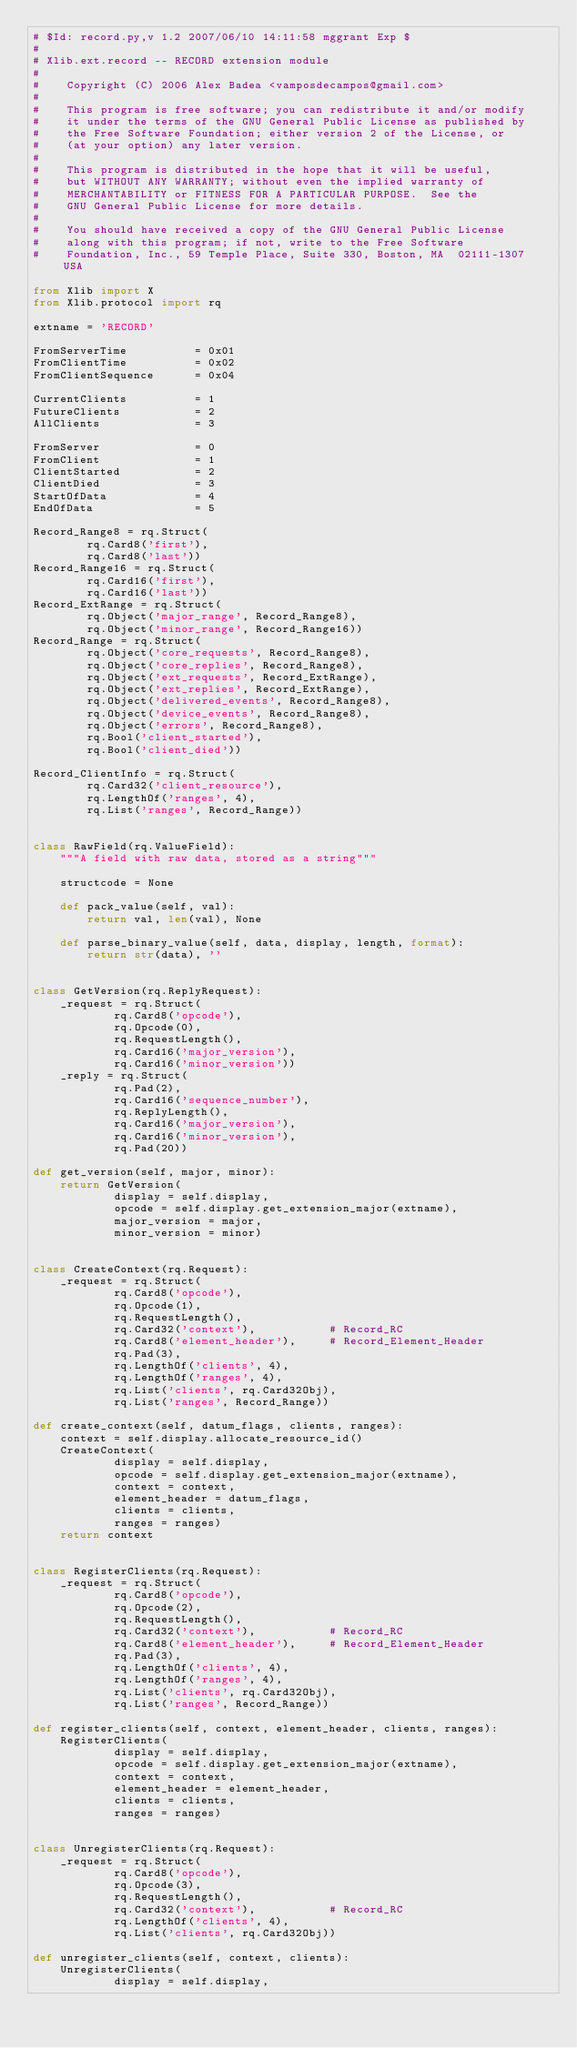Convert code to text. <code><loc_0><loc_0><loc_500><loc_500><_Python_># $Id: record.py,v 1.2 2007/06/10 14:11:58 mggrant Exp $
#
# Xlib.ext.record -- RECORD extension module
#
#    Copyright (C) 2006 Alex Badea <vamposdecampos@gmail.com>
#
#    This program is free software; you can redistribute it and/or modify
#    it under the terms of the GNU General Public License as published by
#    the Free Software Foundation; either version 2 of the License, or
#    (at your option) any later version.
#
#    This program is distributed in the hope that it will be useful,
#    but WITHOUT ANY WARRANTY; without even the implied warranty of
#    MERCHANTABILITY or FITNESS FOR A PARTICULAR PURPOSE.  See the
#    GNU General Public License for more details.
#
#    You should have received a copy of the GNU General Public License
#    along with this program; if not, write to the Free Software
#    Foundation, Inc., 59 Temple Place, Suite 330, Boston, MA  02111-1307  USA

from Xlib import X
from Xlib.protocol import rq

extname = 'RECORD'

FromServerTime          = 0x01
FromClientTime          = 0x02
FromClientSequence      = 0x04

CurrentClients          = 1
FutureClients           = 2
AllClients              = 3

FromServer              = 0
FromClient              = 1
ClientStarted           = 2
ClientDied              = 3
StartOfData             = 4
EndOfData               = 5

Record_Range8 = rq.Struct(
        rq.Card8('first'),
        rq.Card8('last'))
Record_Range16 = rq.Struct(
        rq.Card16('first'),
        rq.Card16('last'))
Record_ExtRange = rq.Struct(
        rq.Object('major_range', Record_Range8),
        rq.Object('minor_range', Record_Range16))
Record_Range = rq.Struct(
        rq.Object('core_requests', Record_Range8),
        rq.Object('core_replies', Record_Range8),
        rq.Object('ext_requests', Record_ExtRange),
        rq.Object('ext_replies', Record_ExtRange),
        rq.Object('delivered_events', Record_Range8),
        rq.Object('device_events', Record_Range8),
        rq.Object('errors', Record_Range8),
        rq.Bool('client_started'),
        rq.Bool('client_died'))

Record_ClientInfo = rq.Struct(
        rq.Card32('client_resource'),
        rq.LengthOf('ranges', 4),
        rq.List('ranges', Record_Range))


class RawField(rq.ValueField):
    """A field with raw data, stored as a string"""

    structcode = None

    def pack_value(self, val):
        return val, len(val), None

    def parse_binary_value(self, data, display, length, format):
        return str(data), ''


class GetVersion(rq.ReplyRequest):
    _request = rq.Struct(
            rq.Card8('opcode'),
            rq.Opcode(0),
            rq.RequestLength(),
            rq.Card16('major_version'),
            rq.Card16('minor_version'))
    _reply = rq.Struct(
            rq.Pad(2),
            rq.Card16('sequence_number'),
            rq.ReplyLength(),
            rq.Card16('major_version'),
            rq.Card16('minor_version'),
            rq.Pad(20))

def get_version(self, major, minor):
    return GetVersion(
            display = self.display,
            opcode = self.display.get_extension_major(extname),
            major_version = major,
            minor_version = minor)


class CreateContext(rq.Request):
    _request = rq.Struct(
            rq.Card8('opcode'),
            rq.Opcode(1),
            rq.RequestLength(),
            rq.Card32('context'),           # Record_RC
            rq.Card8('element_header'),     # Record_Element_Header
            rq.Pad(3),
            rq.LengthOf('clients', 4),
            rq.LengthOf('ranges', 4),
            rq.List('clients', rq.Card32Obj),
            rq.List('ranges', Record_Range))

def create_context(self, datum_flags, clients, ranges):
    context = self.display.allocate_resource_id()
    CreateContext(
            display = self.display,
            opcode = self.display.get_extension_major(extname),
            context = context,
            element_header = datum_flags,
            clients = clients,
            ranges = ranges)
    return context


class RegisterClients(rq.Request):
    _request = rq.Struct(
            rq.Card8('opcode'),
            rq.Opcode(2),
            rq.RequestLength(),
            rq.Card32('context'),           # Record_RC
            rq.Card8('element_header'),     # Record_Element_Header
            rq.Pad(3),
            rq.LengthOf('clients', 4),
            rq.LengthOf('ranges', 4),
            rq.List('clients', rq.Card32Obj),
            rq.List('ranges', Record_Range))

def register_clients(self, context, element_header, clients, ranges):
    RegisterClients(
            display = self.display,
            opcode = self.display.get_extension_major(extname),
            context = context,
            element_header = element_header,
            clients = clients,
            ranges = ranges)


class UnregisterClients(rq.Request):
    _request = rq.Struct(
            rq.Card8('opcode'),
            rq.Opcode(3),
            rq.RequestLength(),
            rq.Card32('context'),           # Record_RC
            rq.LengthOf('clients', 4),
            rq.List('clients', rq.Card32Obj))

def unregister_clients(self, context, clients):
    UnregisterClients(
            display = self.display,</code> 